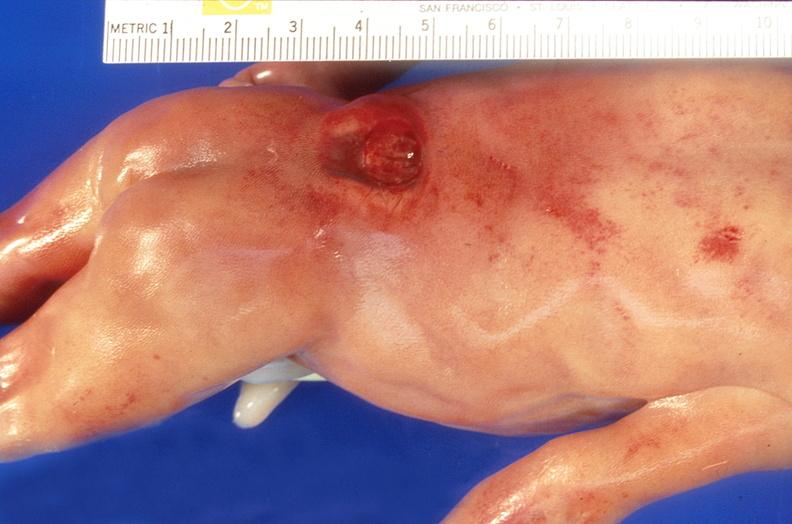does this image show neural tube defect, meningomyelocele?
Answer the question using a single word or phrase. Yes 